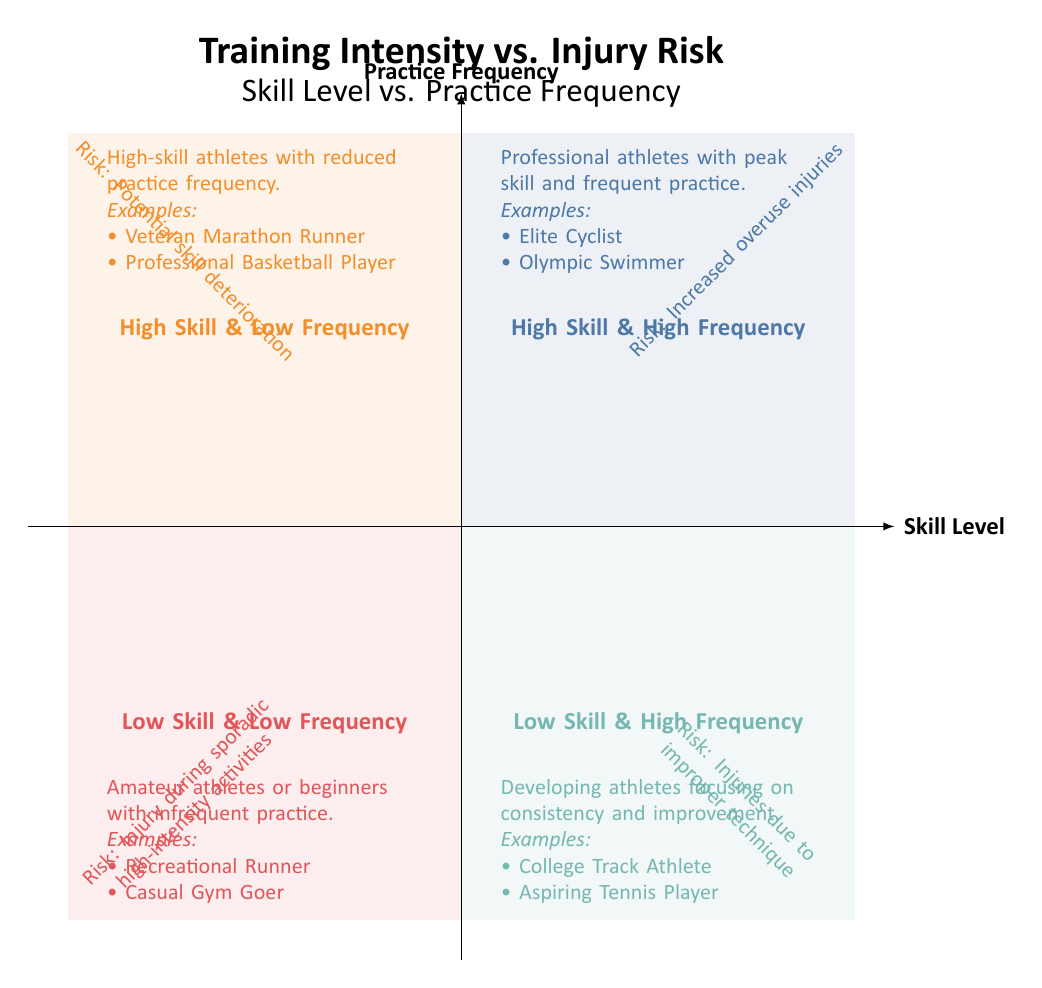What are the titles of the four quadrants? The titles listed in the quadrants are "High Skill & High Frequency," "High Skill & Low Frequency," "Low Skill & Low Frequency," and "Low Skill & High Frequency."
Answer: High Skill & High Frequency, High Skill & Low Frequency, Low Skill & Low Frequency, Low Skill & High Frequency What is the injury risk associated with "High Skill & High Frequency"? In the "High Skill & High Frequency" quadrant, the risk of injury is noted as "Increased risk of overuse injuries."
Answer: Increased risk of overuse injuries How many examples are listed for "Low Skill & Low Frequency"? The "Low Skill & Low Frequency" quadrant contains two examples: "Recreational Runner" and "Casual Gym Goer." Thus, the total count of examples is two.
Answer: 2 What is the main characteristic of the athletes in the "Low Skill & High Frequency" quadrant? Athletes in this quadrant are described as "Developing athletes who train frequently but are still building their skills." This indicates they have low skill level and high training frequency.
Answer: Developing athletes who train frequently What is the relationship between skill level and injury risk in the "High Skill & Low Frequency"? In the "High Skill & Low Frequency" quadrant, the description mentions a reduced risk of acute injuries alongside potential skill deterioration, indicating that while the immediate injury risk is lower, there are concerns about losing skills.
Answer: Reduced risk of acute injuries but potential for skill deterioration What color represents the "Low Skill & Low Frequency" quadrant? On the diagram, the "Low Skill & Low Frequency" quadrant is filled with the color indicated in the legend for that section, which is represented as a specific color code you can see in the chart.
Answer: Light brown Why might an athlete in the "Low Skill & High Frequency" quadrant experience a high risk of injury? This quadrant states that these athletes are at a high risk of injuries due to improper technique, which infers that frequent training without proper skill development increases the likelihood of injury.
Answer: High risk of injuries due to improper technique In what situations might a "High Skill & Low Frequency" athlete reduce their practice? The description in the "High Skill & Low Frequency" quadrant suggests this reduction in practice frequency might occur during recovery periods or off-season training schedules.
Answer: Recovery periods or off-season schedules What is one of the main injuries described for athletes in the "Low Skill & Low Frequency"? The explanation for the "Low Skill & Low Frequency" quadrant indicates a higher potential for injury when engaging in sporadic high-intensity activities because of inconsistent conditioning.
Answer: Injury during sporadic high-intensity activities 